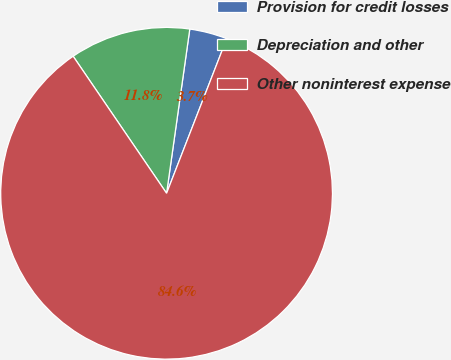<chart> <loc_0><loc_0><loc_500><loc_500><pie_chart><fcel>Provision for credit losses<fcel>Depreciation and other<fcel>Other noninterest expense<nl><fcel>3.67%<fcel>11.76%<fcel>84.57%<nl></chart> 